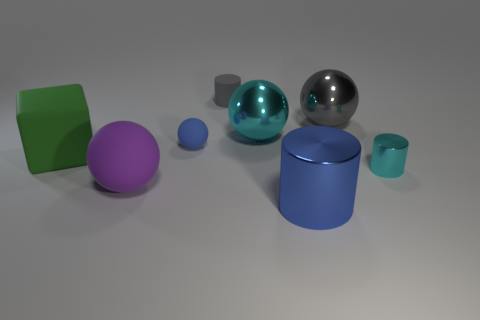What number of yellow rubber things are the same size as the green matte thing?
Your answer should be very brief. 0. There is a big green matte object in front of the blue thing that is behind the big purple ball; how many matte things are in front of it?
Your answer should be compact. 1. What number of cyan things are both right of the big blue metallic thing and to the left of the tiny metallic object?
Give a very brief answer. 0. Is there any other thing of the same color as the rubber cylinder?
Give a very brief answer. Yes. How many metallic objects are large cyan things or big gray objects?
Provide a succinct answer. 2. What material is the cylinder that is on the right side of the metal sphere to the right of the cylinder in front of the cyan cylinder made of?
Provide a short and direct response. Metal. What is the material of the small cylinder on the left side of the cyan shiny thing on the left side of the big gray sphere?
Provide a short and direct response. Rubber. There is a matte sphere that is behind the large purple object; is its size the same as the cyan thing to the right of the large blue metal object?
Make the answer very short. Yes. What number of tiny things are blue balls or cyan metallic things?
Make the answer very short. 2. How many things are shiny cylinders that are in front of the purple rubber ball or yellow things?
Offer a terse response. 1. 